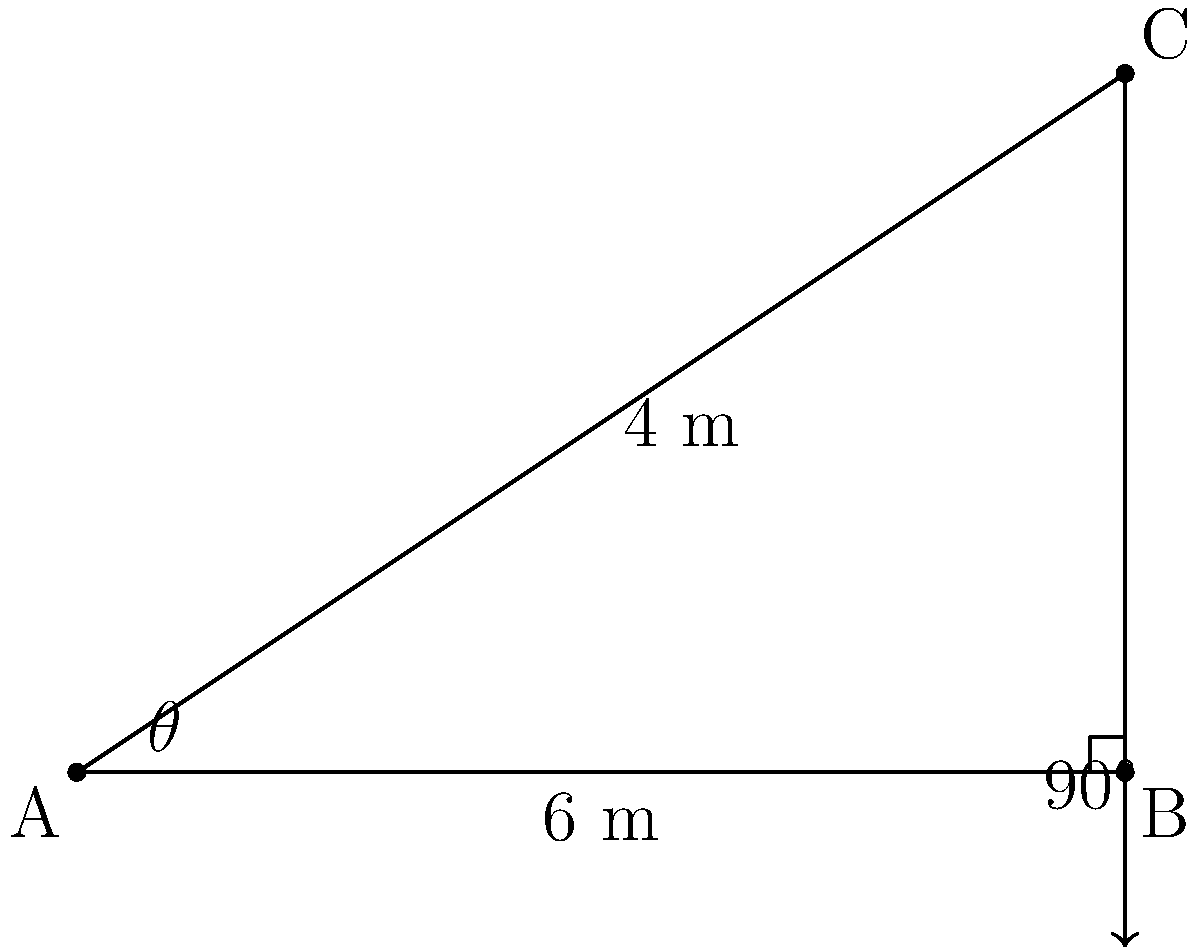Your cousin Otis Yelton is learning about surveying techniques and needs help with a problem. In the diagram, a surveyor stands at point A and measures the distance to a building (point B) as 6 meters. The top of the building (point C) is 4 meters higher than the surveyor's eye level. What is the angle of elevation ($\theta$) from the surveyor's position to the top of the building? To solve this problem, we'll use trigonometry in a right triangle. Let's break it down step-by-step:

1) We have a right triangle ABC, where:
   - AB is the horizontal distance (adjacent to angle $\theta$) = 6 meters
   - BC is the vertical height (opposite to angle $\theta$) = 4 meters
   - AC is the hypotenuse

2) To find the angle of elevation ($\theta$), we need to use the tangent function:

   $\tan(\theta) = \frac{\text{opposite}}{\text{adjacent}}$

3) Substituting our known values:

   $\tan(\theta) = \frac{4}{6}$

4) To get $\theta$, we need to take the inverse tangent (arctan or $\tan^{-1}$) of both sides:

   $\theta = \tan^{-1}(\frac{4}{6})$

5) Using a calculator or trigonometric tables:

   $\theta \approx 33.69^\circ$

6) Rounding to the nearest degree:

   $\theta \approx 34^\circ$

Therefore, the angle of elevation from the surveyor's position to the top of the building is approximately 34°.
Answer: $34^\circ$ 